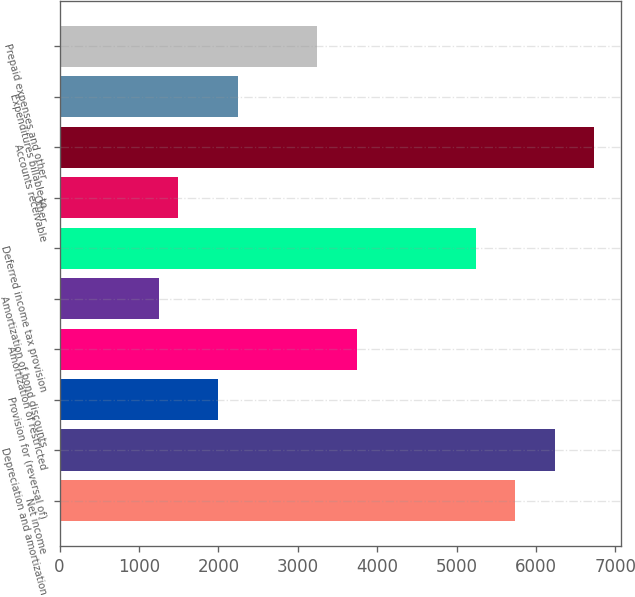Convert chart to OTSL. <chart><loc_0><loc_0><loc_500><loc_500><bar_chart><fcel>Net income<fcel>Depreciation and amortization<fcel>Provision for (reversal of)<fcel>Amortization of restricted<fcel>Amortization of bond discounts<fcel>Deferred income tax provision<fcel>Other<fcel>Accounts receivable<fcel>Expenditures billable to<fcel>Prepaid expenses and other<nl><fcel>5737.4<fcel>6236.2<fcel>1996.4<fcel>3742.2<fcel>1248.2<fcel>5238.6<fcel>1497.6<fcel>6735<fcel>2245.8<fcel>3243.4<nl></chart> 